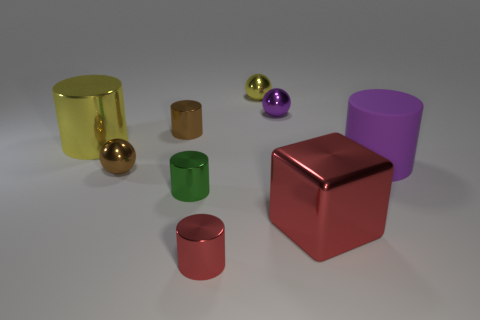Is there any other thing that is made of the same material as the large purple cylinder?
Keep it short and to the point. No. What number of things are either big purple objects or cylinders that are to the left of the metal cube?
Offer a very short reply. 5. Are there any brown shiny objects of the same shape as the small green metallic object?
Provide a succinct answer. Yes. There is a brown object in front of the big cylinder left of the small cylinder that is left of the green shiny cylinder; what is its size?
Your answer should be very brief. Small. Is the number of brown cylinders on the right side of the brown cylinder the same as the number of red things that are to the right of the small red cylinder?
Give a very brief answer. No. The green thing that is made of the same material as the red cylinder is what size?
Offer a terse response. Small. The big metallic cylinder has what color?
Offer a very short reply. Yellow. What number of cylinders are the same color as the big block?
Keep it short and to the point. 1. What material is the cube that is the same size as the yellow metallic cylinder?
Offer a terse response. Metal. Is there a large purple rubber object behind the yellow object to the left of the brown metal sphere?
Provide a short and direct response. No. 